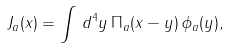Convert formula to latex. <formula><loc_0><loc_0><loc_500><loc_500>J _ { a } ( x ) = \int \, d ^ { 4 } y \, \Pi _ { a } ( x - y ) \, \phi _ { a } ( y ) ,</formula> 